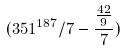Convert formula to latex. <formula><loc_0><loc_0><loc_500><loc_500>( 3 5 1 ^ { 1 8 7 } / 7 - \frac { \frac { 4 2 } { 9 } } { 7 } )</formula> 